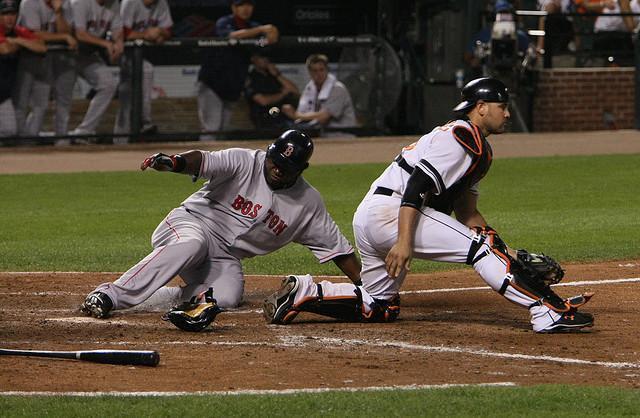How many people are there?
Give a very brief answer. 7. How many trains are on the track?
Give a very brief answer. 0. 